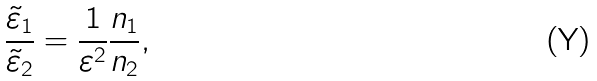<formula> <loc_0><loc_0><loc_500><loc_500>\frac { \tilde { \varepsilon } _ { 1 } } { \tilde { \varepsilon } _ { 2 } } = \frac { 1 } { \varepsilon ^ { 2 } } \frac { n _ { 1 } } { n _ { 2 } } ,</formula> 